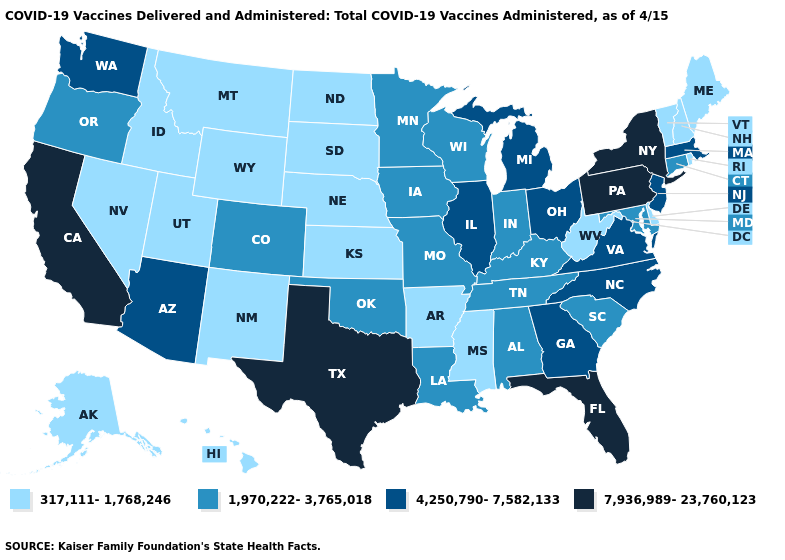Among the states that border Wyoming , does Nebraska have the highest value?
Answer briefly. No. What is the value of Maryland?
Be succinct. 1,970,222-3,765,018. What is the lowest value in the West?
Be succinct. 317,111-1,768,246. Name the states that have a value in the range 4,250,790-7,582,133?
Answer briefly. Arizona, Georgia, Illinois, Massachusetts, Michigan, New Jersey, North Carolina, Ohio, Virginia, Washington. Name the states that have a value in the range 4,250,790-7,582,133?
Keep it brief. Arizona, Georgia, Illinois, Massachusetts, Michigan, New Jersey, North Carolina, Ohio, Virginia, Washington. What is the lowest value in the USA?
Keep it brief. 317,111-1,768,246. Name the states that have a value in the range 1,970,222-3,765,018?
Give a very brief answer. Alabama, Colorado, Connecticut, Indiana, Iowa, Kentucky, Louisiana, Maryland, Minnesota, Missouri, Oklahoma, Oregon, South Carolina, Tennessee, Wisconsin. Does Georgia have the same value as Arizona?
Concise answer only. Yes. Does Pennsylvania have a higher value than New York?
Concise answer only. No. What is the value of Wisconsin?
Write a very short answer. 1,970,222-3,765,018. Which states have the lowest value in the West?
Answer briefly. Alaska, Hawaii, Idaho, Montana, Nevada, New Mexico, Utah, Wyoming. What is the value of Idaho?
Concise answer only. 317,111-1,768,246. Does the first symbol in the legend represent the smallest category?
Answer briefly. Yes. What is the highest value in the Northeast ?
Keep it brief. 7,936,989-23,760,123. Name the states that have a value in the range 4,250,790-7,582,133?
Keep it brief. Arizona, Georgia, Illinois, Massachusetts, Michigan, New Jersey, North Carolina, Ohio, Virginia, Washington. 